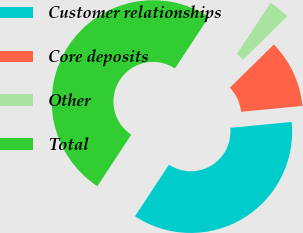Convert chart. <chart><loc_0><loc_0><loc_500><loc_500><pie_chart><fcel>Customer relationships<fcel>Core deposits<fcel>Other<fcel>Total<nl><fcel>35.78%<fcel>10.85%<fcel>3.36%<fcel>50.0%<nl></chart> 